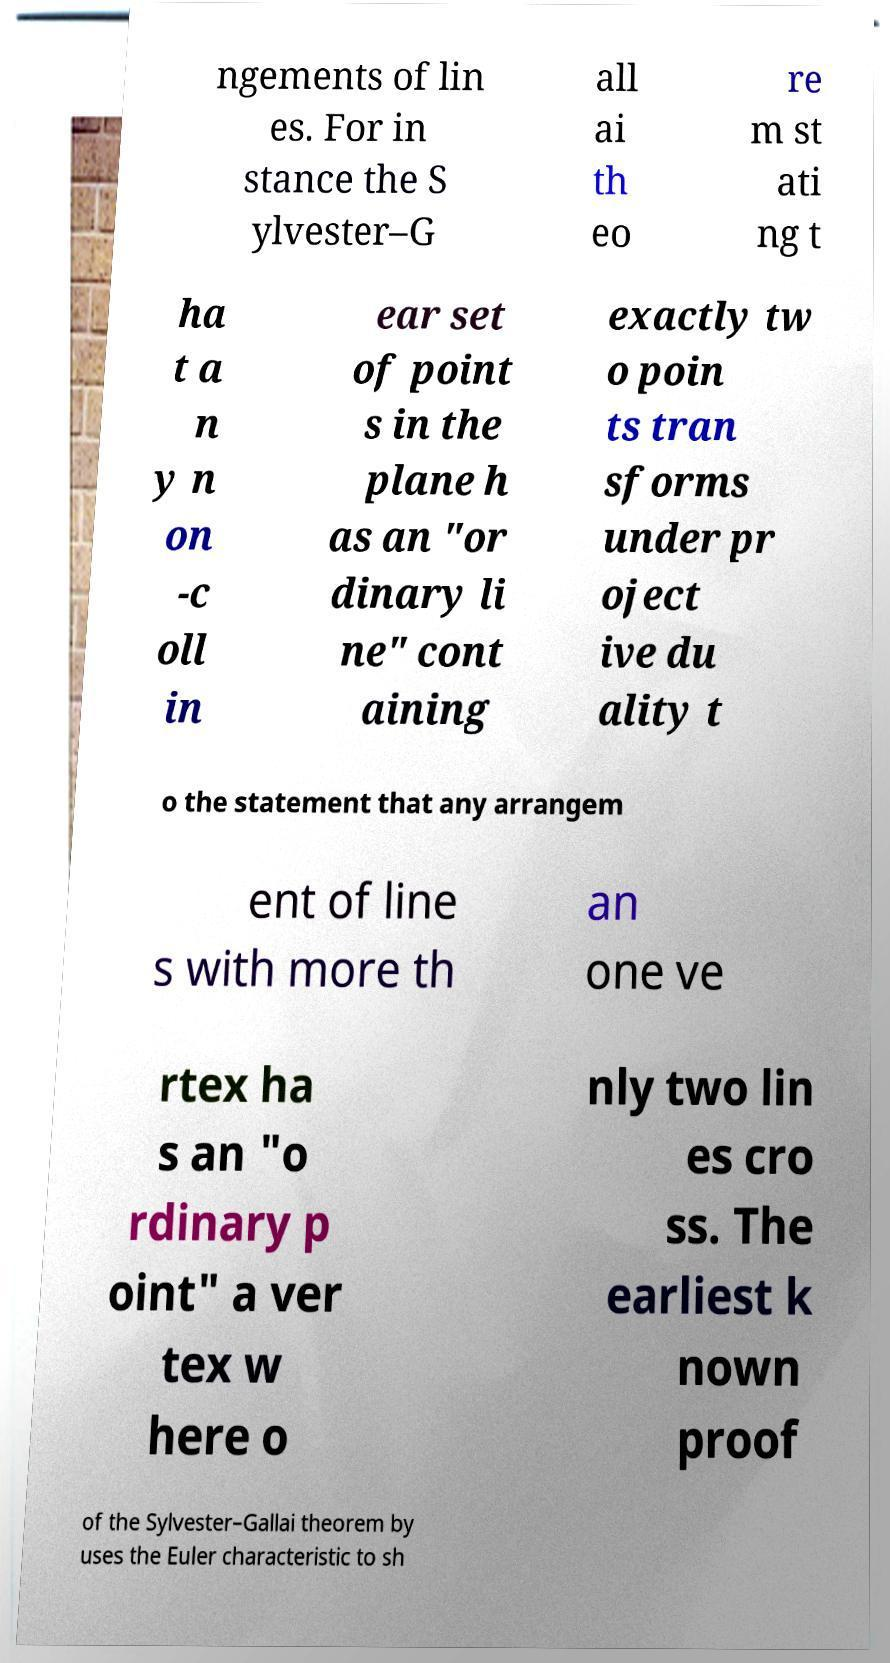There's text embedded in this image that I need extracted. Can you transcribe it verbatim? ngements of lin es. For in stance the S ylvester–G all ai th eo re m st ati ng t ha t a n y n on -c oll in ear set of point s in the plane h as an "or dinary li ne" cont aining exactly tw o poin ts tran sforms under pr oject ive du ality t o the statement that any arrangem ent of line s with more th an one ve rtex ha s an "o rdinary p oint" a ver tex w here o nly two lin es cro ss. The earliest k nown proof of the Sylvester–Gallai theorem by uses the Euler characteristic to sh 